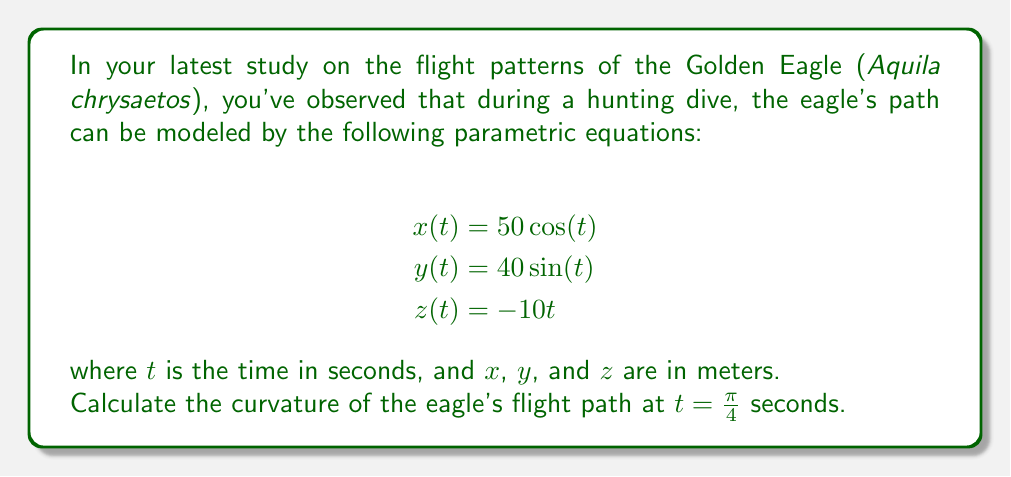Help me with this question. To find the curvature of a 3D parametric curve, we can use the formula:

$$\kappa = \frac{\|\mathbf{r}'(t) \times \mathbf{r}''(t)\|}{\|\mathbf{r}'(t)\|^3}$$

where $\mathbf{r}(t) = (x(t), y(t), z(t))$ is the position vector.

Step 1: Calculate $\mathbf{r}'(t)$ and $\mathbf{r}''(t)$
$$\mathbf{r}'(t) = (-50\sin(t), 40\cos(t), -10)$$
$$\mathbf{r}''(t) = (-50\cos(t), -40\sin(t), 0)$$

Step 2: Calculate $\mathbf{r}'(t) \times \mathbf{r}''(t)$
$$\mathbf{r}'(t) \times \mathbf{r}''(t) = \begin{vmatrix} 
\mathbf{i} & \mathbf{j} & \mathbf{k} \\
-50\sin(t) & 40\cos(t) & -10 \\
-50\cos(t) & -40\sin(t) & 0
\end{vmatrix}$$

$$= (400\sin^2(t) + 500\cos^2(t))\mathbf{i} + (500\sin(t)\cos(t) - 400\sin(t)\cos(t))\mathbf{j} + (2000\sin(t) + 1600\cos(t))\mathbf{k}$$

Step 3: Calculate $\|\mathbf{r}'(t) \times \mathbf{r}''(t)\|$ at $t = \frac{\pi}{4}$
At $t = \frac{\pi}{4}$, $\sin(t) = \cos(t) = \frac{\sqrt{2}}{2}$

$$\|\mathbf{r}'(\frac{\pi}{4}) \times \mathbf{r}''(\frac{\pi}{4})\| = \sqrt{(450^2 + 50^2 + 3600^2)} = 3640.0548$$

Step 4: Calculate $\|\mathbf{r}'(t)\|$ at $t = \frac{\pi}{4}$
$$\|\mathbf{r}'(\frac{\pi}{4})\| = \sqrt{(-50\frac{\sqrt{2}}{2})^2 + (40\frac{\sqrt{2}}{2})^2 + (-10)^2} = 51.4782$$

Step 5: Apply the curvature formula
$$\kappa = \frac{3640.0548}{51.4782^3} = 0.0266$$
Answer: The curvature of the eagle's flight path at $t = \frac{\pi}{4}$ seconds is approximately 0.0266 m$^{-1}$. 